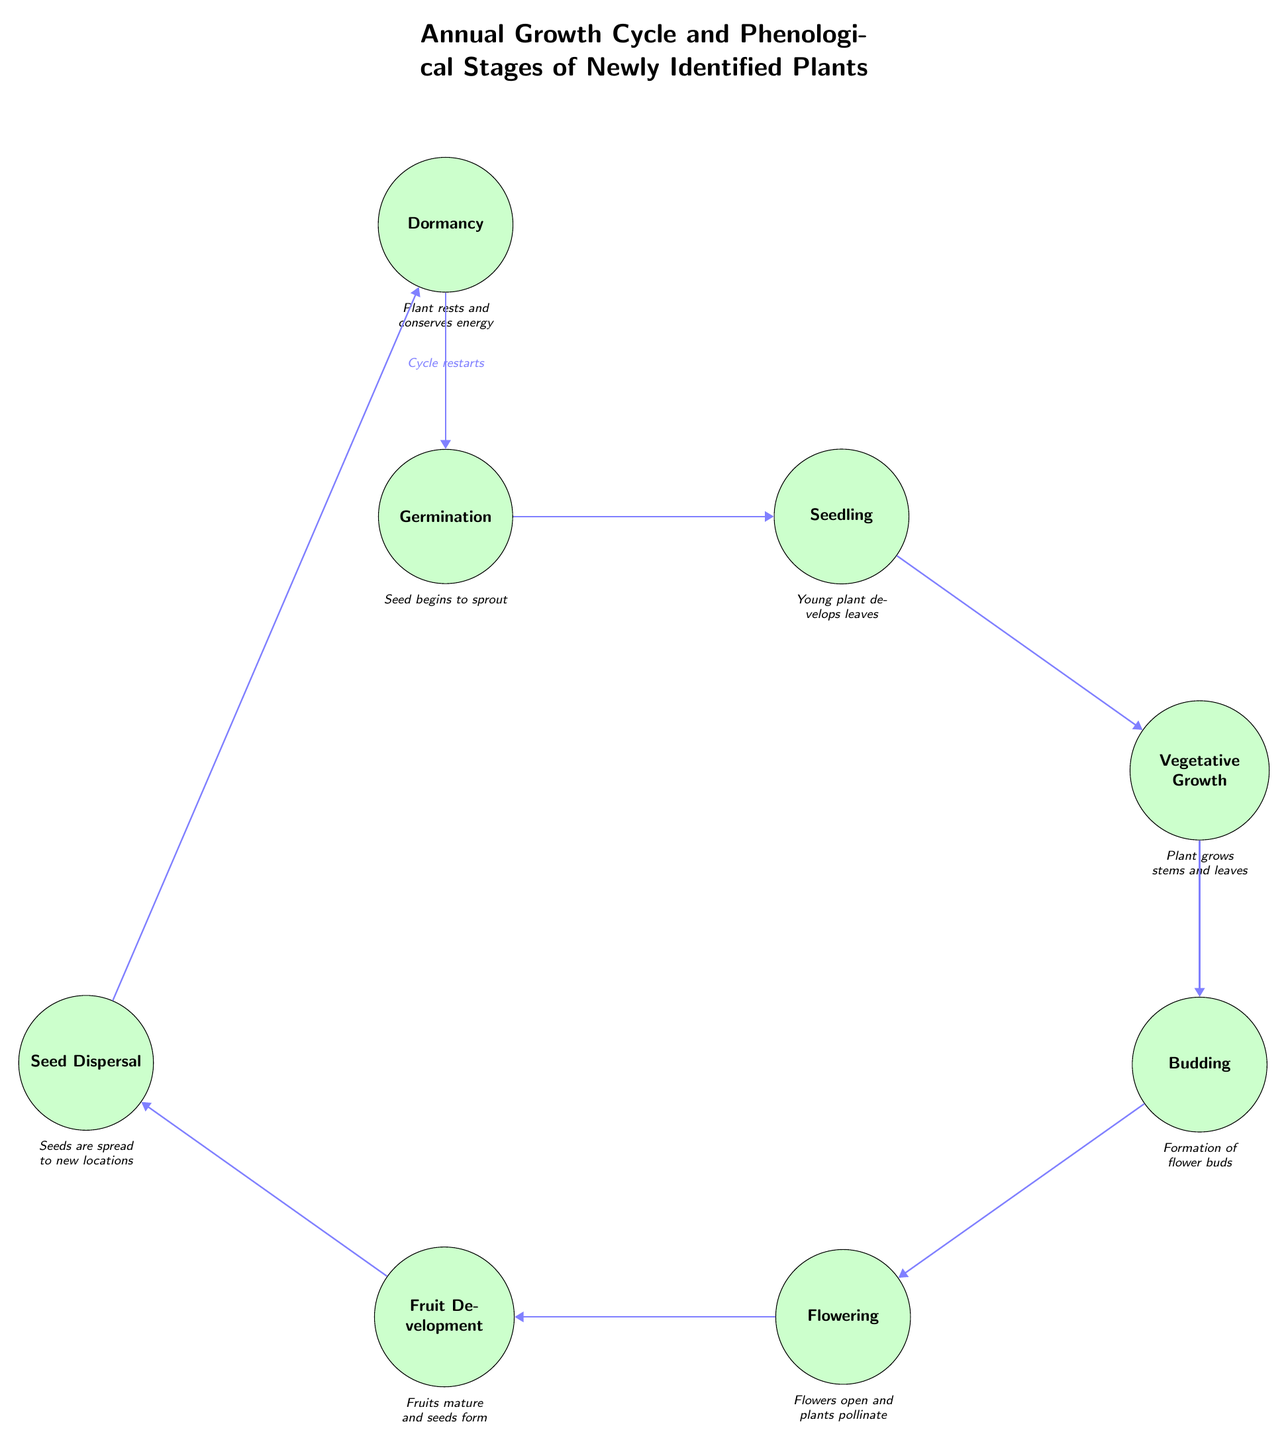What is the first stage in the growth cycle? The first stage in the growth cycle is labeled "Germination" in the diagram.
Answer: Germination How many stages are there in total? By counting from Germination to Dormancy, there are eight distinct stages depicted in the diagram, indicating the various phases of the plants' annual growth cycle.
Answer: Eight What stage follows Flowering? According to the directional arrows in the diagram, the stage that follows Flowering is "Fruit Development".
Answer: Fruit Development What event occurs during the Dormancy stage? The description under the Dormancy stage states that the plant "rests and conserves energy", summarizing what happens during this stage.
Answer: Rests and conserves energy Which two stages are directly connected to the Seed Development stage? The diagram shows that the "Flowering" stage leads into "Fruit Development", and once the fruits are mature, they lead into "Seed Dispersal". Therefore, the stages directly connected to Fruit Development are Flowering and Seed Dispersal.
Answer: Flowering and Seed Dispersal During which stage does pollination occur? The description found under the Flowering stage explicitly mentions that this is when "flowers open and plants pollinate".
Answer: Flowering How does the cycle restart after completing all the stages? The diagram indicates that after the Dormancy stage, it points back to Germination, stating that the cycle restarts.
Answer: Cycle restarts Which stage has the description indicating young plants developing leaves? The Seedling stage has the description "Young plant develops leaves," which directly corresponds to the description provided in the diagram.
Answer: Seedling 